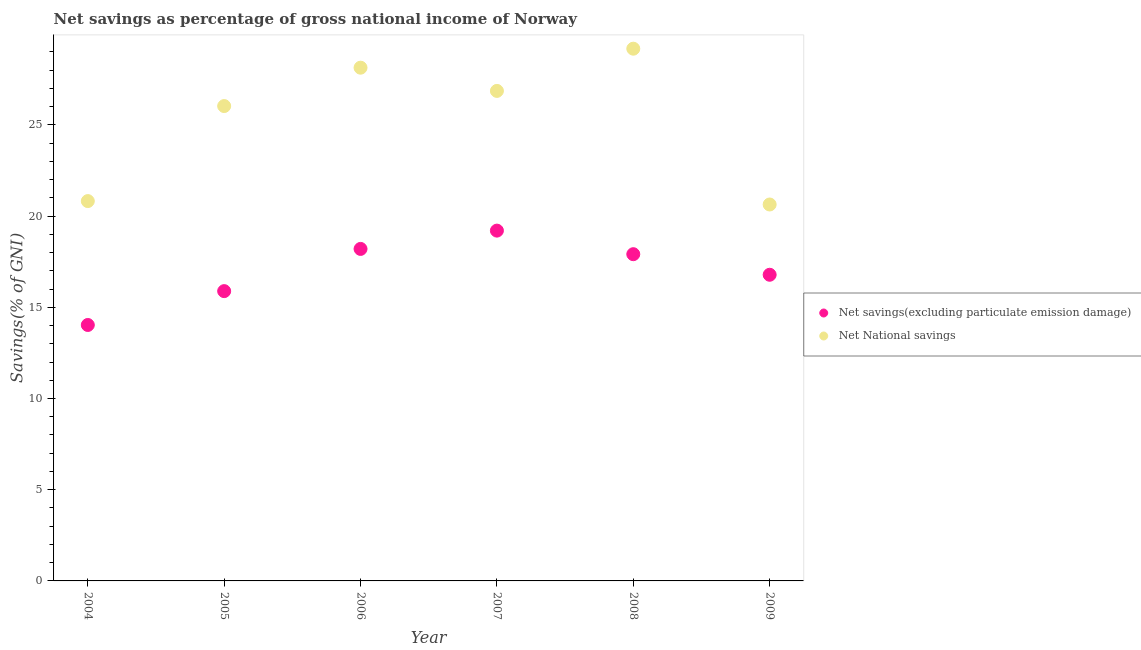What is the net savings(excluding particulate emission damage) in 2008?
Your answer should be very brief. 17.91. Across all years, what is the maximum net national savings?
Keep it short and to the point. 29.18. Across all years, what is the minimum net savings(excluding particulate emission damage)?
Give a very brief answer. 14.03. In which year was the net national savings maximum?
Your response must be concise. 2008. What is the total net national savings in the graph?
Keep it short and to the point. 151.68. What is the difference between the net savings(excluding particulate emission damage) in 2005 and that in 2009?
Give a very brief answer. -0.9. What is the difference between the net national savings in 2007 and the net savings(excluding particulate emission damage) in 2004?
Your response must be concise. 12.83. What is the average net national savings per year?
Your answer should be very brief. 25.28. In the year 2004, what is the difference between the net savings(excluding particulate emission damage) and net national savings?
Your answer should be very brief. -6.79. What is the ratio of the net savings(excluding particulate emission damage) in 2005 to that in 2006?
Keep it short and to the point. 0.87. Is the difference between the net national savings in 2004 and 2005 greater than the difference between the net savings(excluding particulate emission damage) in 2004 and 2005?
Provide a succinct answer. No. What is the difference between the highest and the second highest net national savings?
Provide a short and direct response. 1.04. What is the difference between the highest and the lowest net savings(excluding particulate emission damage)?
Give a very brief answer. 5.17. Is the net national savings strictly greater than the net savings(excluding particulate emission damage) over the years?
Offer a terse response. Yes. How many years are there in the graph?
Ensure brevity in your answer.  6. Are the values on the major ticks of Y-axis written in scientific E-notation?
Provide a succinct answer. No. Does the graph contain any zero values?
Your response must be concise. No. Where does the legend appear in the graph?
Your response must be concise. Center right. What is the title of the graph?
Provide a succinct answer. Net savings as percentage of gross national income of Norway. What is the label or title of the X-axis?
Keep it short and to the point. Year. What is the label or title of the Y-axis?
Offer a very short reply. Savings(% of GNI). What is the Savings(% of GNI) in Net savings(excluding particulate emission damage) in 2004?
Provide a succinct answer. 14.03. What is the Savings(% of GNI) in Net National savings in 2004?
Offer a very short reply. 20.82. What is the Savings(% of GNI) of Net savings(excluding particulate emission damage) in 2005?
Ensure brevity in your answer.  15.89. What is the Savings(% of GNI) of Net National savings in 2005?
Offer a terse response. 26.03. What is the Savings(% of GNI) in Net savings(excluding particulate emission damage) in 2006?
Keep it short and to the point. 18.2. What is the Savings(% of GNI) in Net National savings in 2006?
Provide a short and direct response. 28.14. What is the Savings(% of GNI) in Net savings(excluding particulate emission damage) in 2007?
Your response must be concise. 19.2. What is the Savings(% of GNI) in Net National savings in 2007?
Offer a very short reply. 26.86. What is the Savings(% of GNI) in Net savings(excluding particulate emission damage) in 2008?
Offer a terse response. 17.91. What is the Savings(% of GNI) of Net National savings in 2008?
Your answer should be compact. 29.18. What is the Savings(% of GNI) in Net savings(excluding particulate emission damage) in 2009?
Make the answer very short. 16.78. What is the Savings(% of GNI) in Net National savings in 2009?
Provide a succinct answer. 20.64. Across all years, what is the maximum Savings(% of GNI) in Net savings(excluding particulate emission damage)?
Your response must be concise. 19.2. Across all years, what is the maximum Savings(% of GNI) of Net National savings?
Offer a terse response. 29.18. Across all years, what is the minimum Savings(% of GNI) in Net savings(excluding particulate emission damage)?
Provide a short and direct response. 14.03. Across all years, what is the minimum Savings(% of GNI) in Net National savings?
Your answer should be compact. 20.64. What is the total Savings(% of GNI) of Net savings(excluding particulate emission damage) in the graph?
Keep it short and to the point. 102.02. What is the total Savings(% of GNI) of Net National savings in the graph?
Make the answer very short. 151.68. What is the difference between the Savings(% of GNI) of Net savings(excluding particulate emission damage) in 2004 and that in 2005?
Give a very brief answer. -1.86. What is the difference between the Savings(% of GNI) of Net National savings in 2004 and that in 2005?
Provide a succinct answer. -5.21. What is the difference between the Savings(% of GNI) of Net savings(excluding particulate emission damage) in 2004 and that in 2006?
Provide a succinct answer. -4.17. What is the difference between the Savings(% of GNI) in Net National savings in 2004 and that in 2006?
Offer a terse response. -7.31. What is the difference between the Savings(% of GNI) in Net savings(excluding particulate emission damage) in 2004 and that in 2007?
Give a very brief answer. -5.17. What is the difference between the Savings(% of GNI) in Net National savings in 2004 and that in 2007?
Give a very brief answer. -6.04. What is the difference between the Savings(% of GNI) of Net savings(excluding particulate emission damage) in 2004 and that in 2008?
Make the answer very short. -3.88. What is the difference between the Savings(% of GNI) of Net National savings in 2004 and that in 2008?
Ensure brevity in your answer.  -8.36. What is the difference between the Savings(% of GNI) in Net savings(excluding particulate emission damage) in 2004 and that in 2009?
Keep it short and to the point. -2.75. What is the difference between the Savings(% of GNI) of Net National savings in 2004 and that in 2009?
Offer a very short reply. 0.19. What is the difference between the Savings(% of GNI) in Net savings(excluding particulate emission damage) in 2005 and that in 2006?
Make the answer very short. -2.31. What is the difference between the Savings(% of GNI) of Net National savings in 2005 and that in 2006?
Your answer should be very brief. -2.1. What is the difference between the Savings(% of GNI) in Net savings(excluding particulate emission damage) in 2005 and that in 2007?
Your answer should be compact. -3.32. What is the difference between the Savings(% of GNI) in Net National savings in 2005 and that in 2007?
Keep it short and to the point. -0.83. What is the difference between the Savings(% of GNI) in Net savings(excluding particulate emission damage) in 2005 and that in 2008?
Your answer should be compact. -2.02. What is the difference between the Savings(% of GNI) in Net National savings in 2005 and that in 2008?
Offer a very short reply. -3.14. What is the difference between the Savings(% of GNI) of Net savings(excluding particulate emission damage) in 2005 and that in 2009?
Provide a succinct answer. -0.9. What is the difference between the Savings(% of GNI) in Net National savings in 2005 and that in 2009?
Make the answer very short. 5.4. What is the difference between the Savings(% of GNI) in Net savings(excluding particulate emission damage) in 2006 and that in 2007?
Ensure brevity in your answer.  -1. What is the difference between the Savings(% of GNI) in Net National savings in 2006 and that in 2007?
Ensure brevity in your answer.  1.27. What is the difference between the Savings(% of GNI) of Net savings(excluding particulate emission damage) in 2006 and that in 2008?
Offer a terse response. 0.29. What is the difference between the Savings(% of GNI) of Net National savings in 2006 and that in 2008?
Ensure brevity in your answer.  -1.04. What is the difference between the Savings(% of GNI) of Net savings(excluding particulate emission damage) in 2006 and that in 2009?
Offer a very short reply. 1.42. What is the difference between the Savings(% of GNI) of Net National savings in 2006 and that in 2009?
Provide a short and direct response. 7.5. What is the difference between the Savings(% of GNI) of Net savings(excluding particulate emission damage) in 2007 and that in 2008?
Your response must be concise. 1.29. What is the difference between the Savings(% of GNI) in Net National savings in 2007 and that in 2008?
Offer a terse response. -2.31. What is the difference between the Savings(% of GNI) of Net savings(excluding particulate emission damage) in 2007 and that in 2009?
Your answer should be compact. 2.42. What is the difference between the Savings(% of GNI) of Net National savings in 2007 and that in 2009?
Your answer should be very brief. 6.23. What is the difference between the Savings(% of GNI) of Net savings(excluding particulate emission damage) in 2008 and that in 2009?
Your answer should be compact. 1.13. What is the difference between the Savings(% of GNI) in Net National savings in 2008 and that in 2009?
Provide a succinct answer. 8.54. What is the difference between the Savings(% of GNI) in Net savings(excluding particulate emission damage) in 2004 and the Savings(% of GNI) in Net National savings in 2005?
Offer a very short reply. -12. What is the difference between the Savings(% of GNI) of Net savings(excluding particulate emission damage) in 2004 and the Savings(% of GNI) of Net National savings in 2006?
Provide a short and direct response. -14.11. What is the difference between the Savings(% of GNI) in Net savings(excluding particulate emission damage) in 2004 and the Savings(% of GNI) in Net National savings in 2007?
Your answer should be compact. -12.83. What is the difference between the Savings(% of GNI) of Net savings(excluding particulate emission damage) in 2004 and the Savings(% of GNI) of Net National savings in 2008?
Give a very brief answer. -15.15. What is the difference between the Savings(% of GNI) in Net savings(excluding particulate emission damage) in 2004 and the Savings(% of GNI) in Net National savings in 2009?
Ensure brevity in your answer.  -6.61. What is the difference between the Savings(% of GNI) of Net savings(excluding particulate emission damage) in 2005 and the Savings(% of GNI) of Net National savings in 2006?
Provide a short and direct response. -12.25. What is the difference between the Savings(% of GNI) in Net savings(excluding particulate emission damage) in 2005 and the Savings(% of GNI) in Net National savings in 2007?
Your answer should be compact. -10.98. What is the difference between the Savings(% of GNI) in Net savings(excluding particulate emission damage) in 2005 and the Savings(% of GNI) in Net National savings in 2008?
Offer a terse response. -13.29. What is the difference between the Savings(% of GNI) of Net savings(excluding particulate emission damage) in 2005 and the Savings(% of GNI) of Net National savings in 2009?
Offer a very short reply. -4.75. What is the difference between the Savings(% of GNI) in Net savings(excluding particulate emission damage) in 2006 and the Savings(% of GNI) in Net National savings in 2007?
Provide a succinct answer. -8.66. What is the difference between the Savings(% of GNI) of Net savings(excluding particulate emission damage) in 2006 and the Savings(% of GNI) of Net National savings in 2008?
Give a very brief answer. -10.98. What is the difference between the Savings(% of GNI) of Net savings(excluding particulate emission damage) in 2006 and the Savings(% of GNI) of Net National savings in 2009?
Provide a short and direct response. -2.44. What is the difference between the Savings(% of GNI) of Net savings(excluding particulate emission damage) in 2007 and the Savings(% of GNI) of Net National savings in 2008?
Provide a succinct answer. -9.97. What is the difference between the Savings(% of GNI) of Net savings(excluding particulate emission damage) in 2007 and the Savings(% of GNI) of Net National savings in 2009?
Keep it short and to the point. -1.43. What is the difference between the Savings(% of GNI) of Net savings(excluding particulate emission damage) in 2008 and the Savings(% of GNI) of Net National savings in 2009?
Make the answer very short. -2.72. What is the average Savings(% of GNI) in Net savings(excluding particulate emission damage) per year?
Your answer should be very brief. 17. What is the average Savings(% of GNI) of Net National savings per year?
Your response must be concise. 25.28. In the year 2004, what is the difference between the Savings(% of GNI) of Net savings(excluding particulate emission damage) and Savings(% of GNI) of Net National savings?
Ensure brevity in your answer.  -6.79. In the year 2005, what is the difference between the Savings(% of GNI) of Net savings(excluding particulate emission damage) and Savings(% of GNI) of Net National savings?
Ensure brevity in your answer.  -10.15. In the year 2006, what is the difference between the Savings(% of GNI) in Net savings(excluding particulate emission damage) and Savings(% of GNI) in Net National savings?
Give a very brief answer. -9.94. In the year 2007, what is the difference between the Savings(% of GNI) of Net savings(excluding particulate emission damage) and Savings(% of GNI) of Net National savings?
Your answer should be compact. -7.66. In the year 2008, what is the difference between the Savings(% of GNI) of Net savings(excluding particulate emission damage) and Savings(% of GNI) of Net National savings?
Your answer should be very brief. -11.27. In the year 2009, what is the difference between the Savings(% of GNI) of Net savings(excluding particulate emission damage) and Savings(% of GNI) of Net National savings?
Keep it short and to the point. -3.85. What is the ratio of the Savings(% of GNI) of Net savings(excluding particulate emission damage) in 2004 to that in 2005?
Make the answer very short. 0.88. What is the ratio of the Savings(% of GNI) of Net National savings in 2004 to that in 2005?
Offer a terse response. 0.8. What is the ratio of the Savings(% of GNI) of Net savings(excluding particulate emission damage) in 2004 to that in 2006?
Your response must be concise. 0.77. What is the ratio of the Savings(% of GNI) of Net National savings in 2004 to that in 2006?
Provide a succinct answer. 0.74. What is the ratio of the Savings(% of GNI) in Net savings(excluding particulate emission damage) in 2004 to that in 2007?
Keep it short and to the point. 0.73. What is the ratio of the Savings(% of GNI) of Net National savings in 2004 to that in 2007?
Give a very brief answer. 0.78. What is the ratio of the Savings(% of GNI) in Net savings(excluding particulate emission damage) in 2004 to that in 2008?
Your response must be concise. 0.78. What is the ratio of the Savings(% of GNI) in Net National savings in 2004 to that in 2008?
Keep it short and to the point. 0.71. What is the ratio of the Savings(% of GNI) in Net savings(excluding particulate emission damage) in 2004 to that in 2009?
Give a very brief answer. 0.84. What is the ratio of the Savings(% of GNI) in Net National savings in 2004 to that in 2009?
Keep it short and to the point. 1.01. What is the ratio of the Savings(% of GNI) of Net savings(excluding particulate emission damage) in 2005 to that in 2006?
Your response must be concise. 0.87. What is the ratio of the Savings(% of GNI) of Net National savings in 2005 to that in 2006?
Ensure brevity in your answer.  0.93. What is the ratio of the Savings(% of GNI) of Net savings(excluding particulate emission damage) in 2005 to that in 2007?
Your response must be concise. 0.83. What is the ratio of the Savings(% of GNI) in Net National savings in 2005 to that in 2007?
Your answer should be very brief. 0.97. What is the ratio of the Savings(% of GNI) of Net savings(excluding particulate emission damage) in 2005 to that in 2008?
Provide a succinct answer. 0.89. What is the ratio of the Savings(% of GNI) in Net National savings in 2005 to that in 2008?
Offer a terse response. 0.89. What is the ratio of the Savings(% of GNI) in Net savings(excluding particulate emission damage) in 2005 to that in 2009?
Offer a very short reply. 0.95. What is the ratio of the Savings(% of GNI) of Net National savings in 2005 to that in 2009?
Offer a terse response. 1.26. What is the ratio of the Savings(% of GNI) of Net savings(excluding particulate emission damage) in 2006 to that in 2007?
Make the answer very short. 0.95. What is the ratio of the Savings(% of GNI) of Net National savings in 2006 to that in 2007?
Offer a terse response. 1.05. What is the ratio of the Savings(% of GNI) in Net savings(excluding particulate emission damage) in 2006 to that in 2008?
Give a very brief answer. 1.02. What is the ratio of the Savings(% of GNI) in Net savings(excluding particulate emission damage) in 2006 to that in 2009?
Your answer should be very brief. 1.08. What is the ratio of the Savings(% of GNI) of Net National savings in 2006 to that in 2009?
Your response must be concise. 1.36. What is the ratio of the Savings(% of GNI) in Net savings(excluding particulate emission damage) in 2007 to that in 2008?
Offer a very short reply. 1.07. What is the ratio of the Savings(% of GNI) of Net National savings in 2007 to that in 2008?
Your response must be concise. 0.92. What is the ratio of the Savings(% of GNI) of Net savings(excluding particulate emission damage) in 2007 to that in 2009?
Offer a very short reply. 1.14. What is the ratio of the Savings(% of GNI) of Net National savings in 2007 to that in 2009?
Provide a short and direct response. 1.3. What is the ratio of the Savings(% of GNI) of Net savings(excluding particulate emission damage) in 2008 to that in 2009?
Offer a terse response. 1.07. What is the ratio of the Savings(% of GNI) of Net National savings in 2008 to that in 2009?
Keep it short and to the point. 1.41. What is the difference between the highest and the second highest Savings(% of GNI) in Net National savings?
Keep it short and to the point. 1.04. What is the difference between the highest and the lowest Savings(% of GNI) in Net savings(excluding particulate emission damage)?
Make the answer very short. 5.17. What is the difference between the highest and the lowest Savings(% of GNI) of Net National savings?
Provide a short and direct response. 8.54. 